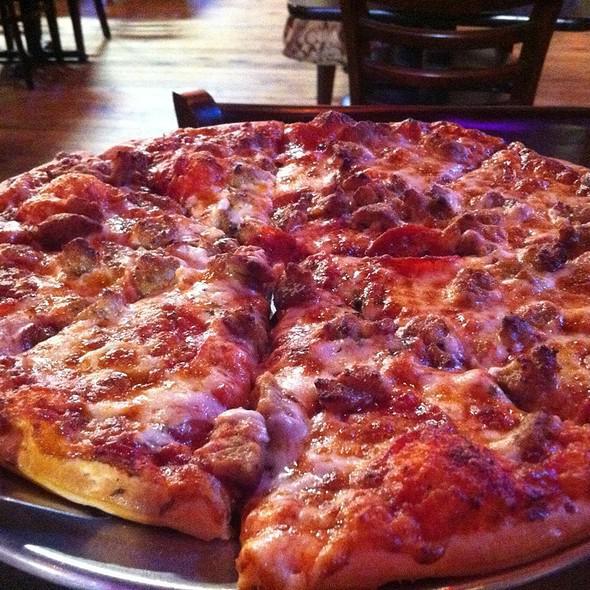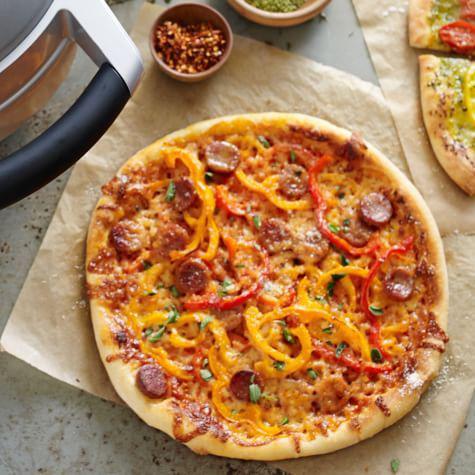The first image is the image on the left, the second image is the image on the right. Assess this claim about the two images: "No pizza is missing a slice, but the pizza on the left has one slice out of alignment with the rest and is on a silver tray.". Correct or not? Answer yes or no. Yes. The first image is the image on the left, the second image is the image on the right. Given the left and right images, does the statement "There are at least 8 slices of a pizza sitting on top of a silver circle plate." hold true? Answer yes or no. Yes. 